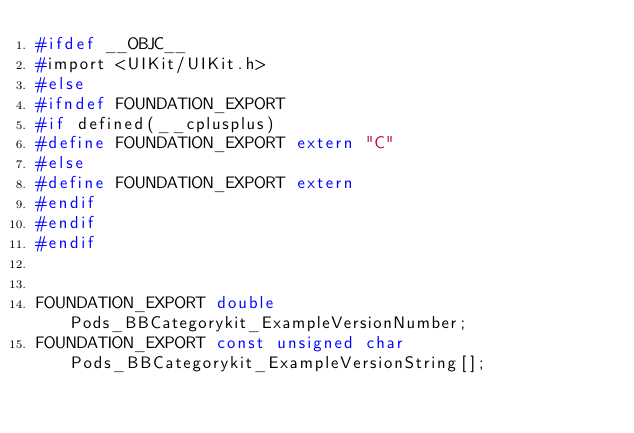<code> <loc_0><loc_0><loc_500><loc_500><_C_>#ifdef __OBJC__
#import <UIKit/UIKit.h>
#else
#ifndef FOUNDATION_EXPORT
#if defined(__cplusplus)
#define FOUNDATION_EXPORT extern "C"
#else
#define FOUNDATION_EXPORT extern
#endif
#endif
#endif


FOUNDATION_EXPORT double Pods_BBCategorykit_ExampleVersionNumber;
FOUNDATION_EXPORT const unsigned char Pods_BBCategorykit_ExampleVersionString[];

</code> 